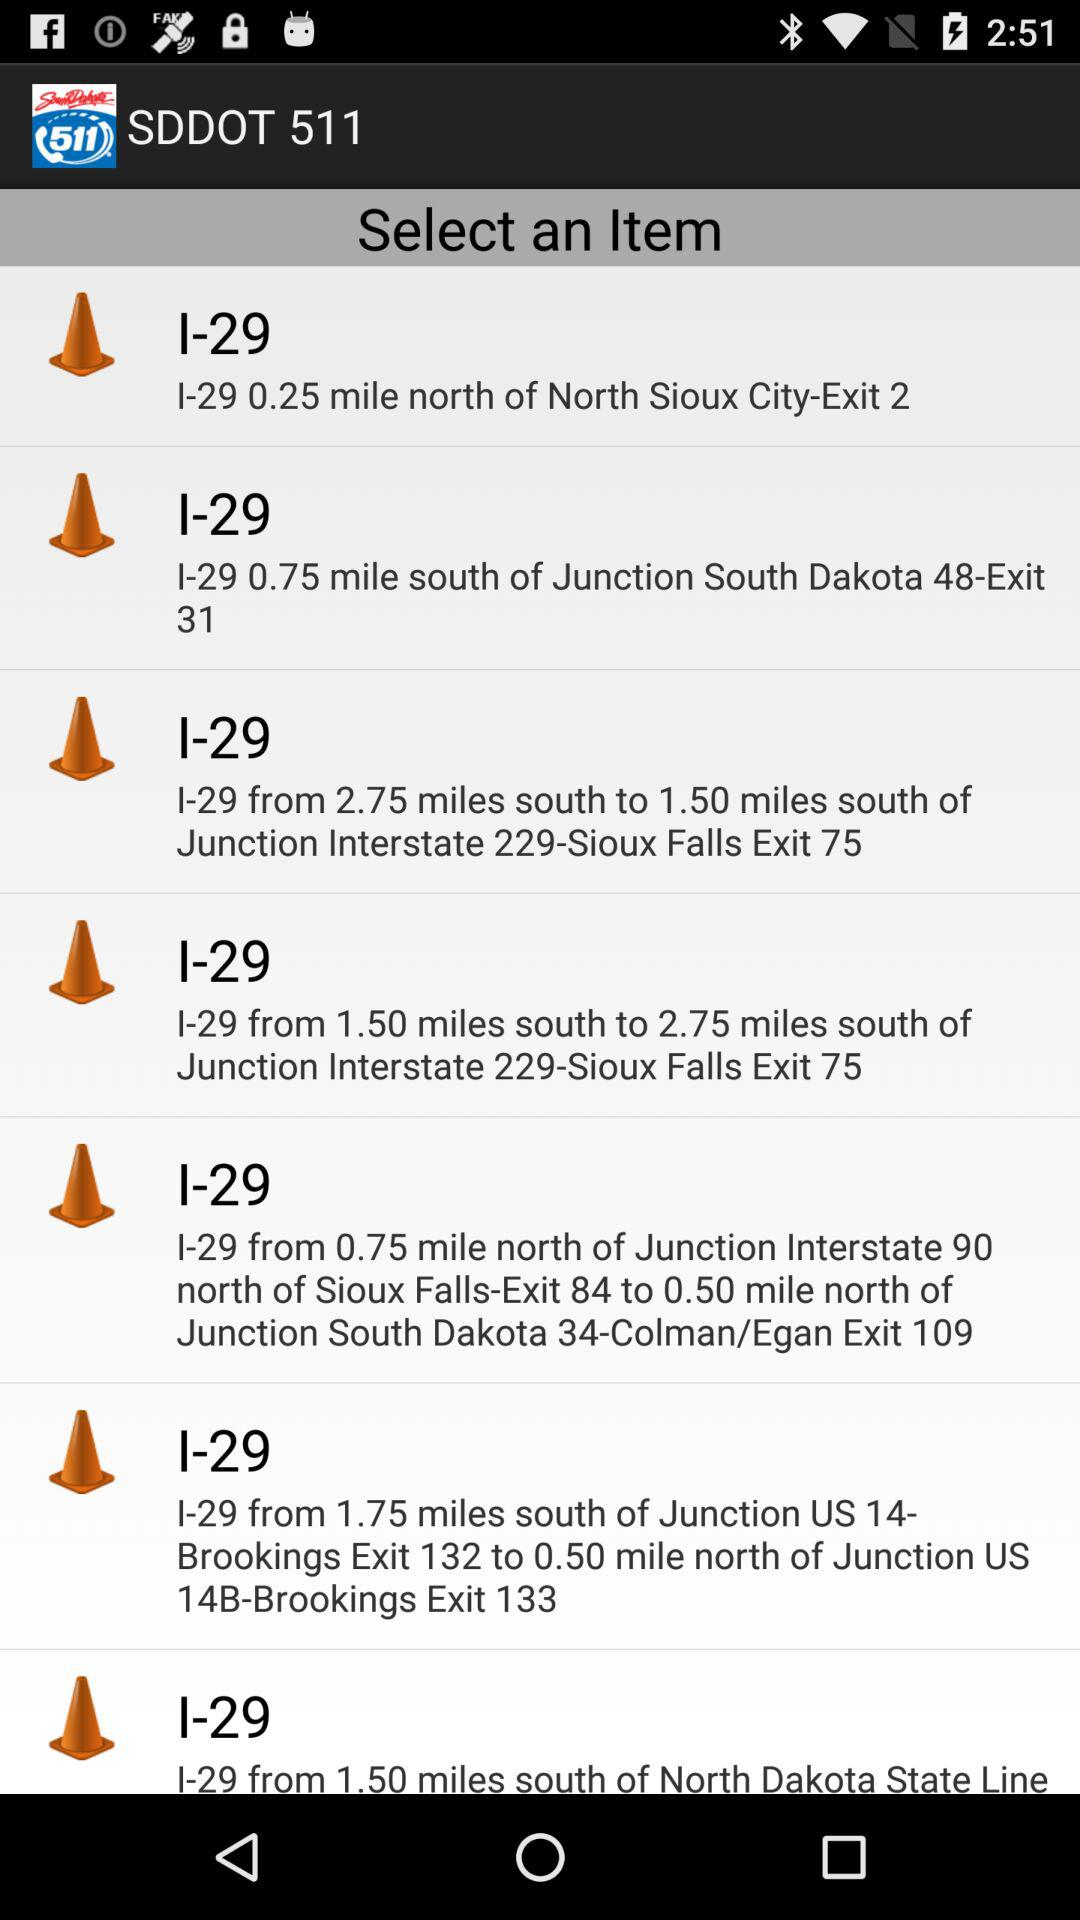I-29 is how much miles from south of Junction south dakota 48-Exit 31? I-29 is 0.75 miles from south of Junction south dakota 48-Exit 31. 